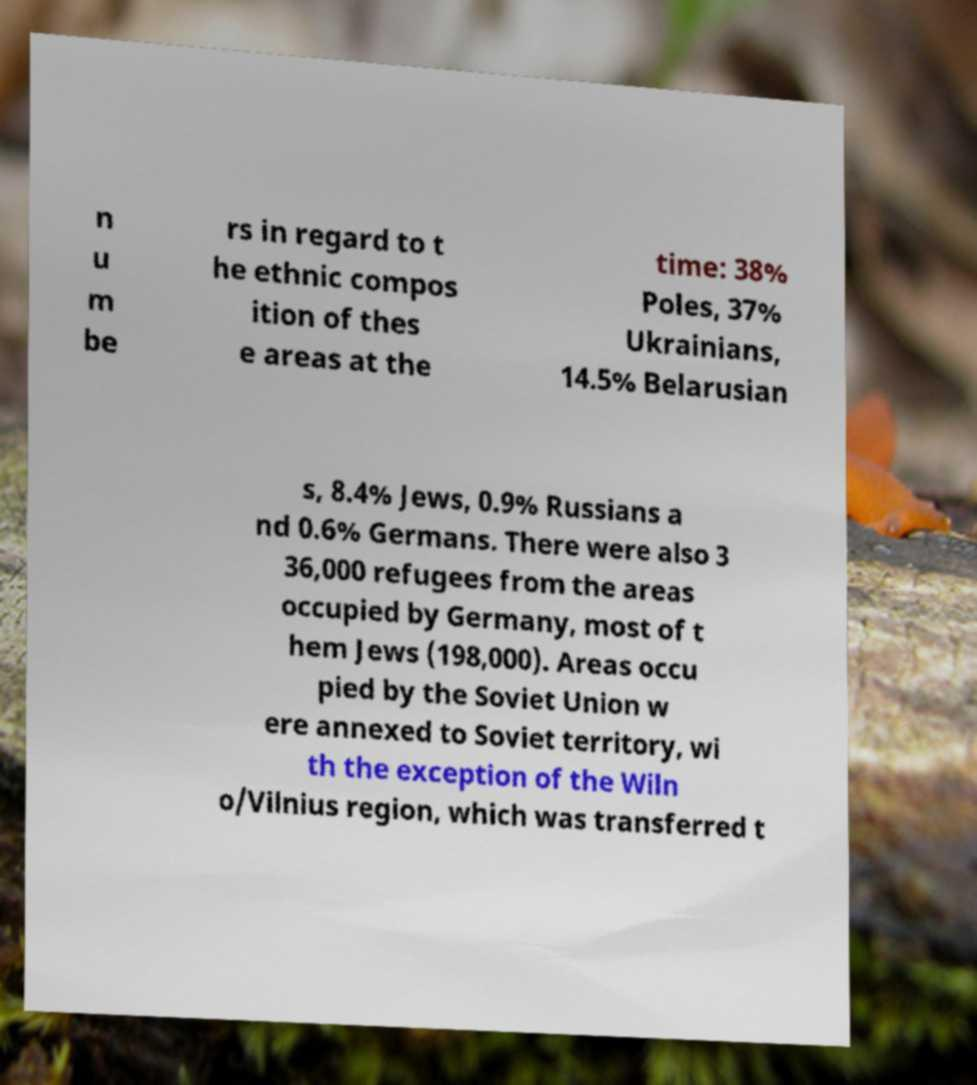Could you extract and type out the text from this image? n u m be rs in regard to t he ethnic compos ition of thes e areas at the time: 38% Poles, 37% Ukrainians, 14.5% Belarusian s, 8.4% Jews, 0.9% Russians a nd 0.6% Germans. There were also 3 36,000 refugees from the areas occupied by Germany, most of t hem Jews (198,000). Areas occu pied by the Soviet Union w ere annexed to Soviet territory, wi th the exception of the Wiln o/Vilnius region, which was transferred t 